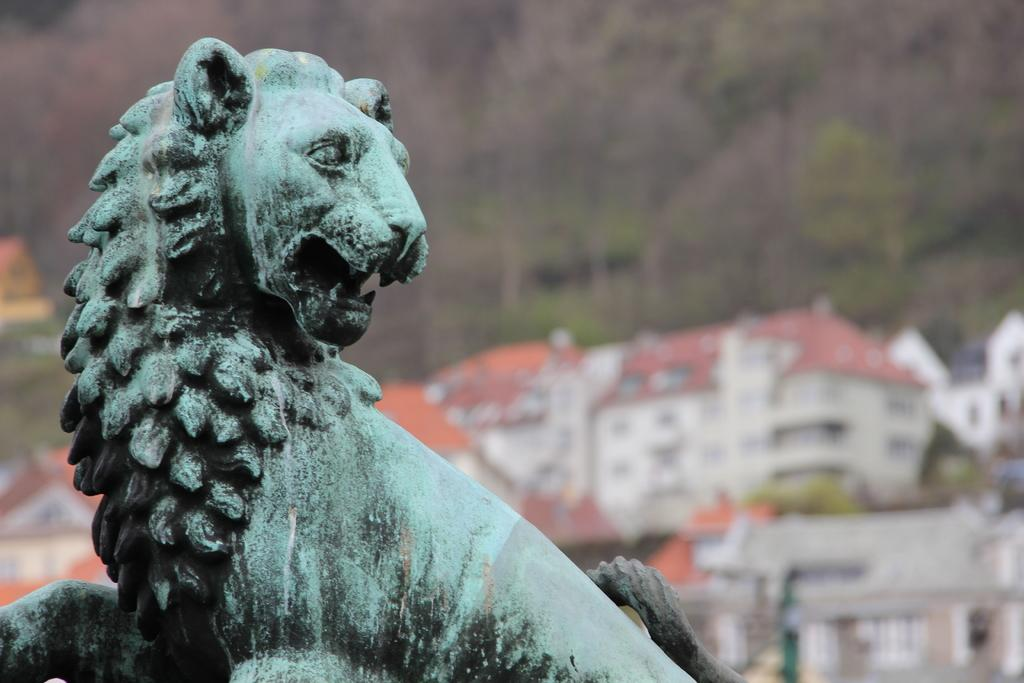What is the main subject of the image? There is a statue of a lion in the image. Can you describe the background of the statue? The background of the statue is blurred. What type of clouds can be seen in the image? There are no clouds present in the image, as it features a statue of a lion with a blurred background. 